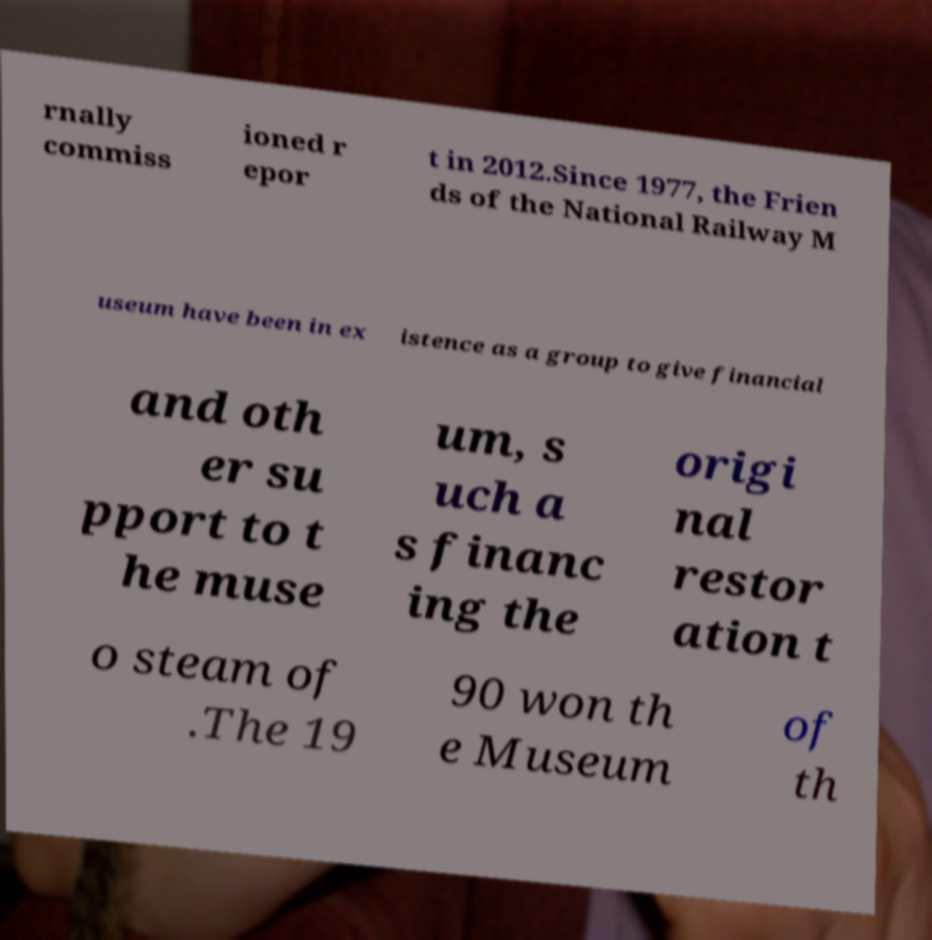Please identify and transcribe the text found in this image. rnally commiss ioned r epor t in 2012.Since 1977, the Frien ds of the National Railway M useum have been in ex istence as a group to give financial and oth er su pport to t he muse um, s uch a s financ ing the origi nal restor ation t o steam of .The 19 90 won th e Museum of th 